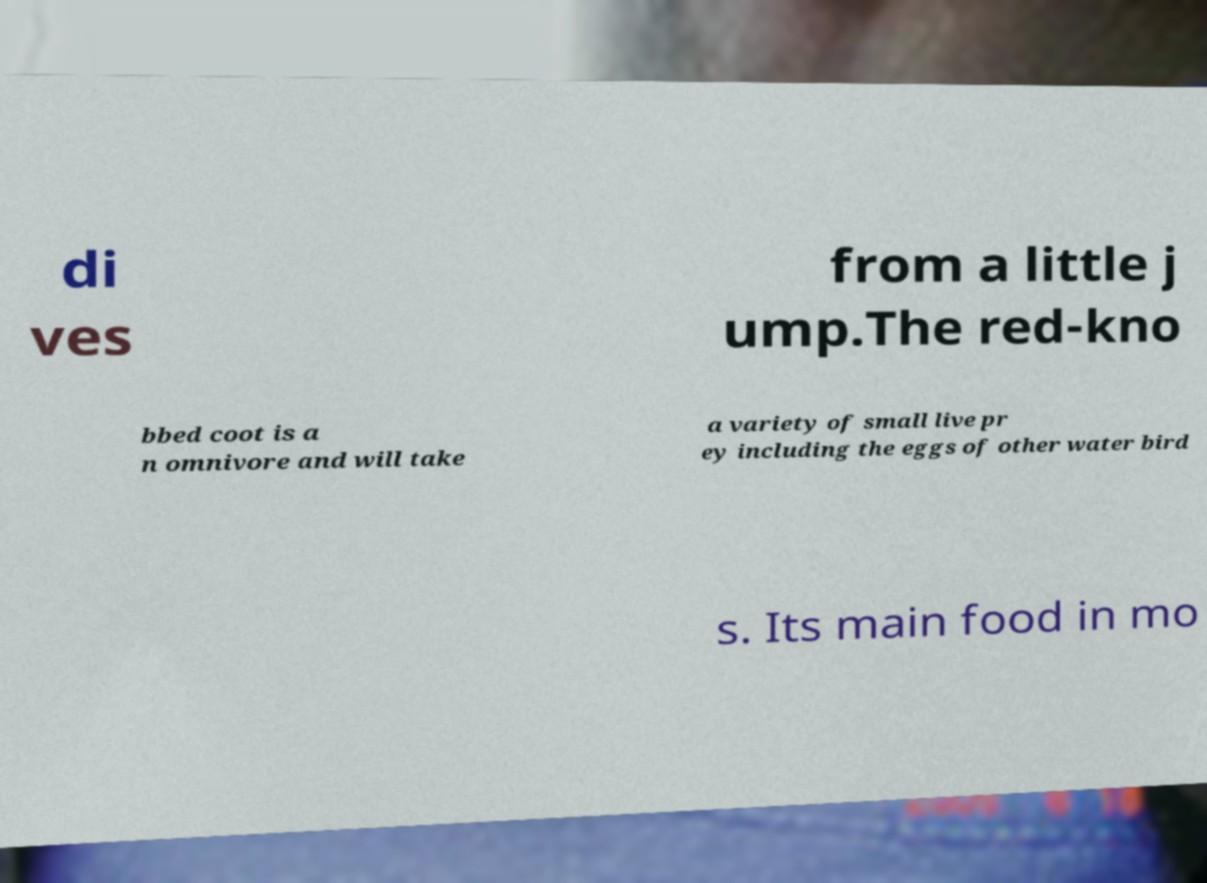For documentation purposes, I need the text within this image transcribed. Could you provide that? di ves from a little j ump.The red-kno bbed coot is a n omnivore and will take a variety of small live pr ey including the eggs of other water bird s. Its main food in mo 